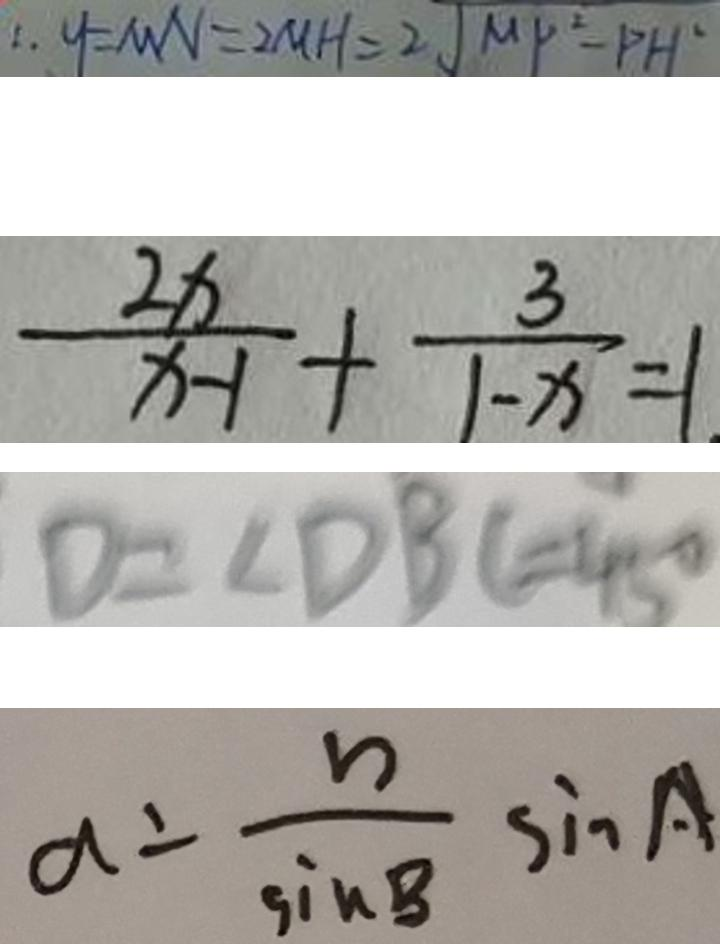Convert formula to latex. <formula><loc_0><loc_0><loc_500><loc_500>\therefore y = M N = 2 M H = 2 \sqrt { M P ^ { 2 } - P H ^ { 2 } } 
 \frac { 2 x } { x - 1 } + \frac { 3 } { 1 - x } = 1 . 
 D = \angle D B C = 4 5 ^ { \circ } 
 a = \frac { b } { \sin B } \sin A</formula> 